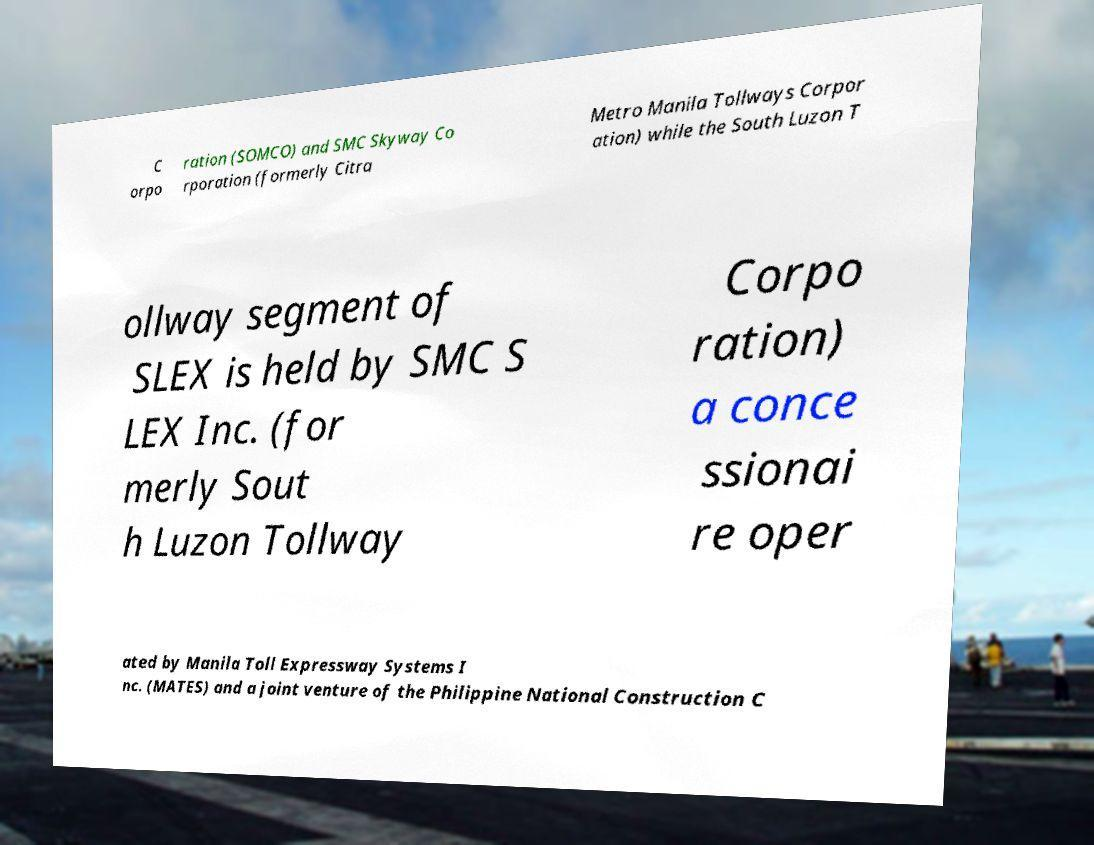Could you extract and type out the text from this image? C orpo ration (SOMCO) and SMC Skyway Co rporation (formerly Citra Metro Manila Tollways Corpor ation) while the South Luzon T ollway segment of SLEX is held by SMC S LEX Inc. (for merly Sout h Luzon Tollway Corpo ration) a conce ssionai re oper ated by Manila Toll Expressway Systems I nc. (MATES) and a joint venture of the Philippine National Construction C 